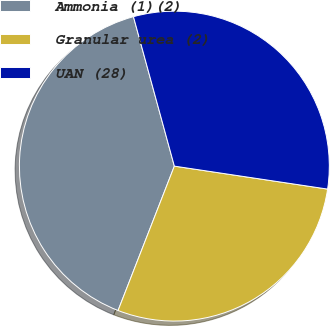Convert chart to OTSL. <chart><loc_0><loc_0><loc_500><loc_500><pie_chart><fcel>Ammonia (1)(2)<fcel>Granular urea (2)<fcel>UAN (28)<nl><fcel>39.83%<fcel>28.55%<fcel>31.62%<nl></chart> 